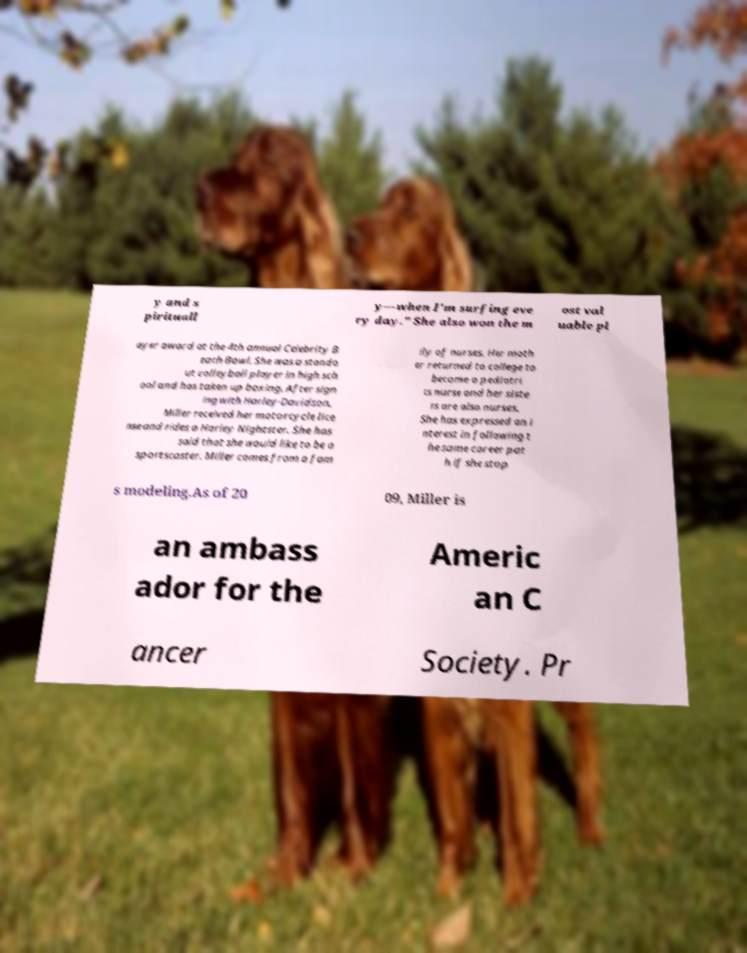There's text embedded in this image that I need extracted. Can you transcribe it verbatim? y and s pirituall y—when I'm surfing eve ry day." She also won the m ost val uable pl ayer award at the 4th annual Celebrity B each Bowl. She was a stando ut volleyball player in high sch ool and has taken up boxing. After sign ing with Harley-Davidson, Miller received her motorcycle lice nse and rides a Harley Nightster. She has said that she would like to be a sportscaster. Miller comes from a fam ily of nurses. Her moth er returned to college to become a pediatri cs nurse and her siste rs are also nurses. She has expressed an i nterest in following t he same career pat h if she stop s modeling.As of 20 09, Miller is an ambass ador for the Americ an C ancer Society. Pr 